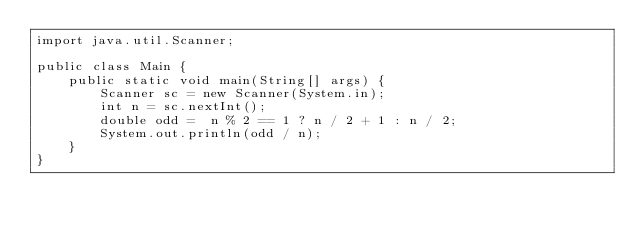<code> <loc_0><loc_0><loc_500><loc_500><_Java_>import java.util.Scanner;

public class Main {
    public static void main(String[] args) {
        Scanner sc = new Scanner(System.in);
        int n = sc.nextInt();
        double odd =  n % 2 == 1 ? n / 2 + 1 : n / 2;
        System.out.println(odd / n);
    }
}
</code> 